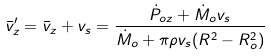<formula> <loc_0><loc_0><loc_500><loc_500>\bar { v } _ { z } ^ { \prime } = \bar { v } _ { z } + v _ { s } = \frac { \dot { P } _ { o z } + \dot { M } _ { o } v _ { s } } { \dot { M } _ { o } + \pi \rho v _ { s } ( R ^ { 2 } - R _ { o } ^ { 2 } ) }</formula> 